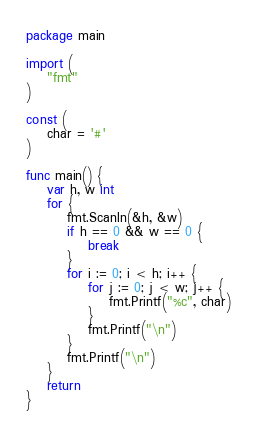Convert code to text. <code><loc_0><loc_0><loc_500><loc_500><_Go_>package main

import (
	"fmt"
)

const (
	char = '#'
)

func main() {
	var h, w int
	for {
		fmt.Scanln(&h, &w)
		if h == 0 && w == 0 {
			break
		}
		for i := 0; i < h; i++ {
			for j := 0; j < w; j++ {
				fmt.Printf("%c", char)
			}
			fmt.Printf("\n")
		}
		fmt.Printf("\n")
	}
	return
}

</code> 